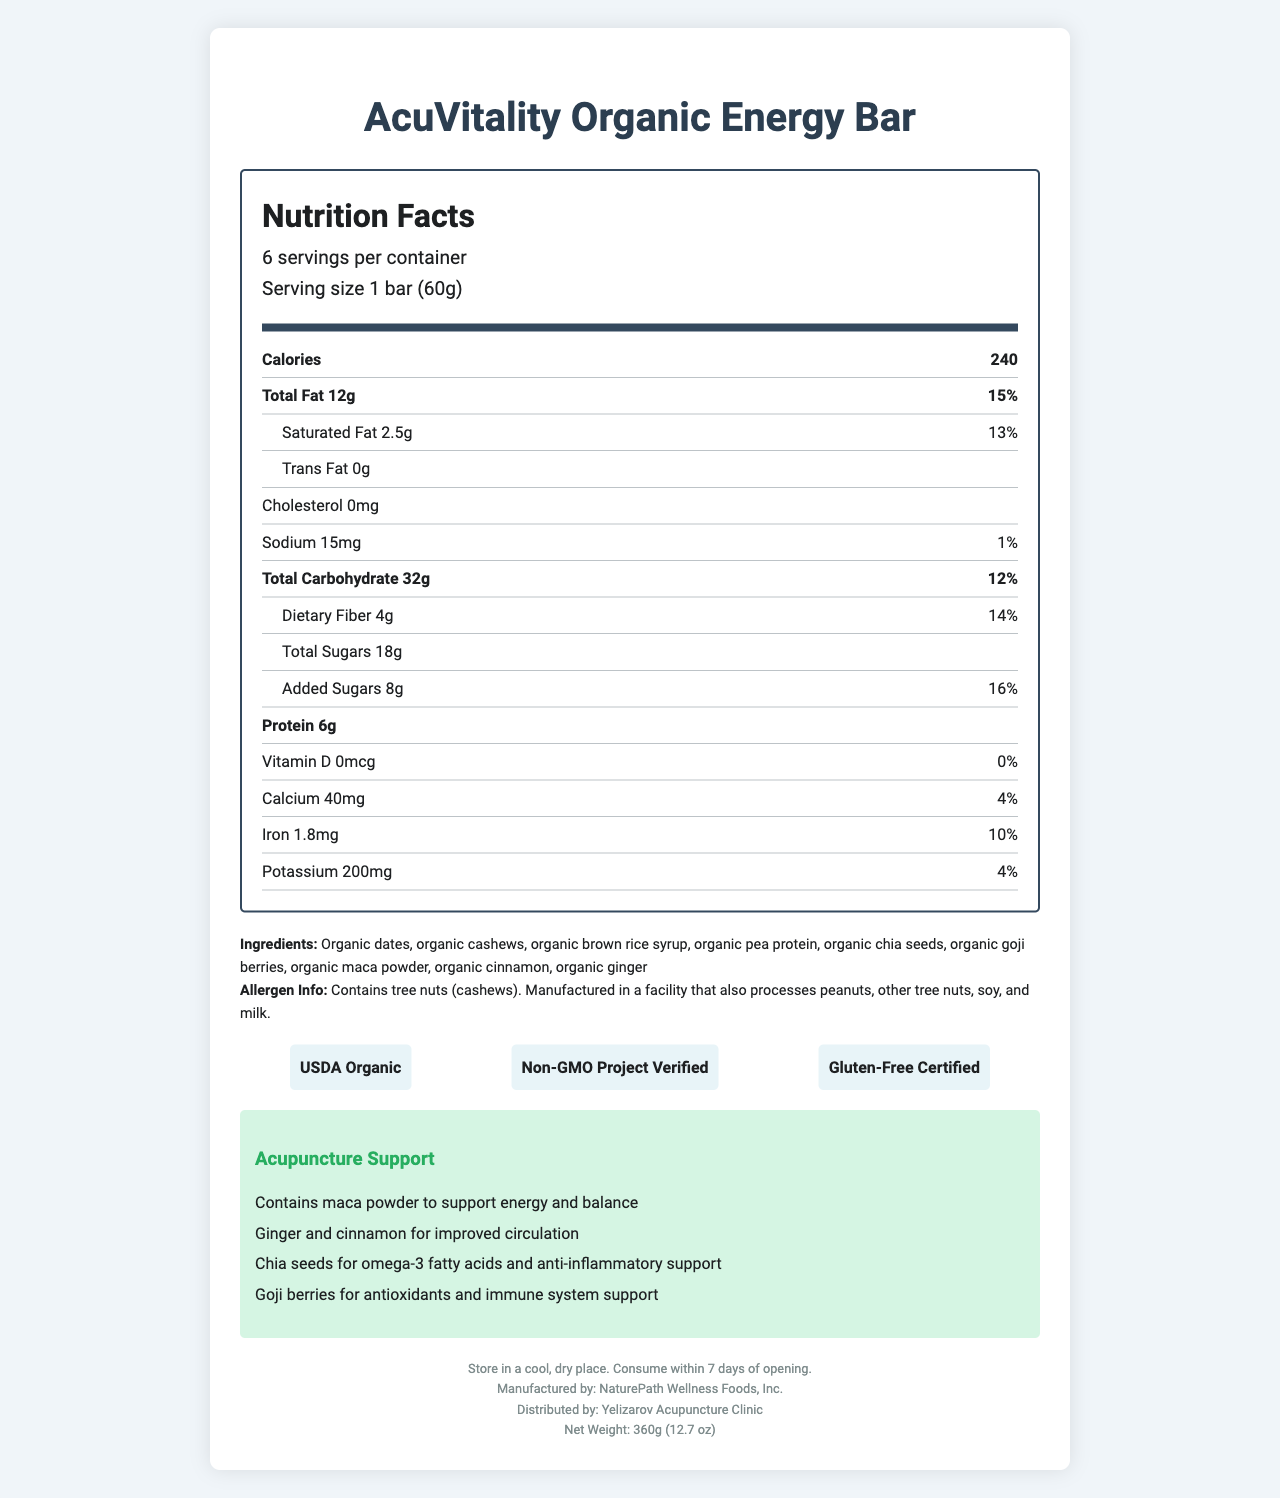what is the serving size of the AcuVitality Organic Energy Bar? The serving size is stated clearly in the "serving size" section of the document.
Answer: 1 bar (60g) how many calories are in one bar? The calorie count is mentioned in the "Calories" section of the nutrition facts.
Answer: 240 what is the total fat content per serving? The total fat content is listed in the "Total Fat" section of the nutrition facts.
Answer: 12g how much potassium is in one bar? The amount of potassium is given in the "Potassium" section of the nutrition facts.
Answer: 200mg list two ingredients in the AcuVitality Organic Energy Bar. The ingredients list includes various organic ingredients, including organic dates and organic cashews.
Answer: Organic dates, organic cashews which of the following certifications does the AcuVitality Organic Energy Bar have? A. USDA Organic B. Fair Trade Certified C. Gluten-Free Certified The certifications listed include "USDA Organic" and "Gluten-Free Certified."
Answer: A and C how many grams of dietary fiber are in each bar? A. 2g B. 4g C. 8g D. 6g The dietary fiber content is noted as 4g in the "Dietary Fiber" section.
Answer: B does the product contain any added sugars? The nutrition facts specify 8g of added sugars, with a daily value of 16%.
Answer: Yes is the AcuVitality Organic Energy Bar gluten-free? It is explicitly mentioned under the certifications section that the product is Gluten-Free Certified.
Answer: Yes what is the storage instruction for the energy bars? The storage instructions are clearly listed under the "storage instructions" section.
Answer: Store in a cool, dry place. Consume within 7 days of opening. describe the benefits of the AcuVitality Organic Energy Bar in relation to acupuncture support. The document mentions several ingredients that support acupuncture treatment by providing energy, circulation, anti-inflammatory properties, and immune support.
Answer: The energy bar contains maca powder to support energy and balance, ginger and cinnamon for improved circulation, chia seeds for omega-3 fatty acids and anti-inflammatory support, and goji berries for antioxidants and immune system support. who is the manufacturer of the AcuVitality Organic Energy Bar? The manufactured-by details confirm that NaturePath Wellness Foods, Inc. is the producer.
Answer: NaturePath Wellness Foods, Inc. which distributing company is responsible for the AcuVitality Organic Energy Bar? The distributed-by section identifies Yelizarov Acupuncture Clinic as the distributor.
Answer: Yelizarov Acupuncture Clinic does the document specify the price of the energy bar? The document does not provide any information on the price of the energy bar.
Answer: Cannot be determined 